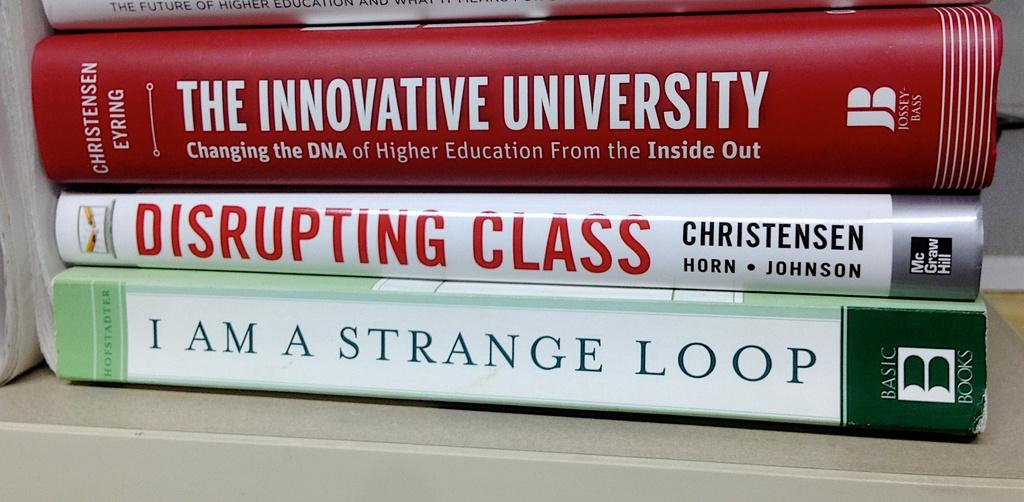<image>
Create a compact narrative representing the image presented. The book "I am a Strange Loop" sits at the bottom of a stack of books. 